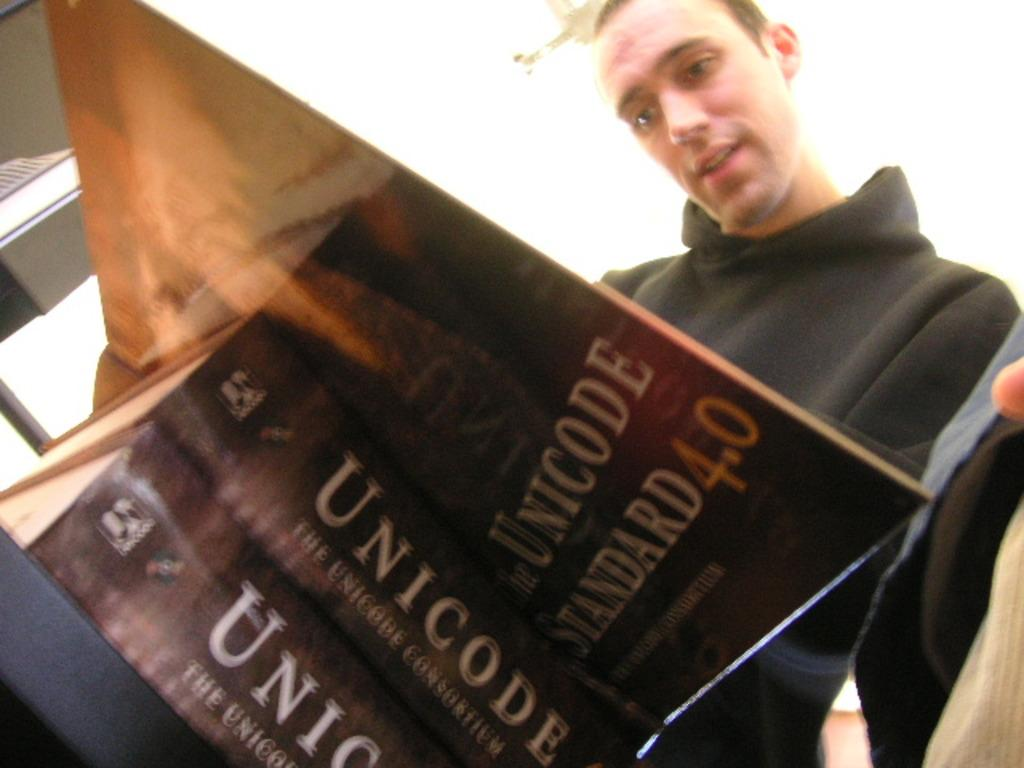<image>
Provide a brief description of the given image. Boy in a black hood is reading a book about unicode 